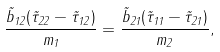<formula> <loc_0><loc_0><loc_500><loc_500>\frac { \tilde { b } _ { 1 2 } ( \tilde { \tau } _ { 2 2 } - \tilde { \tau } _ { 1 2 } ) } { m _ { 1 } } = \frac { \tilde { b } _ { 2 1 } ( \tilde { \tau } _ { 1 1 } - \tilde { \tau } _ { 2 1 } ) } { m _ { 2 } } ,</formula> 